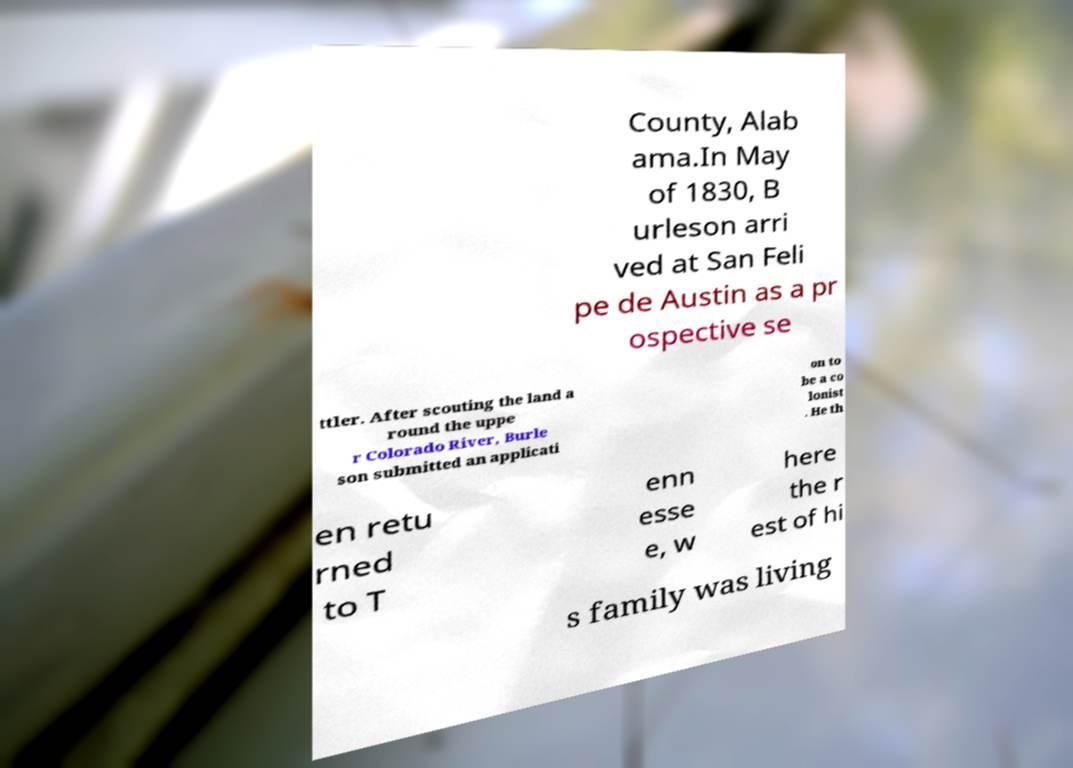For documentation purposes, I need the text within this image transcribed. Could you provide that? County, Alab ama.In May of 1830, B urleson arri ved at San Feli pe de Austin as a pr ospective se ttler. After scouting the land a round the uppe r Colorado River, Burle son submitted an applicati on to be a co lonist . He th en retu rned to T enn esse e, w here the r est of hi s family was living 